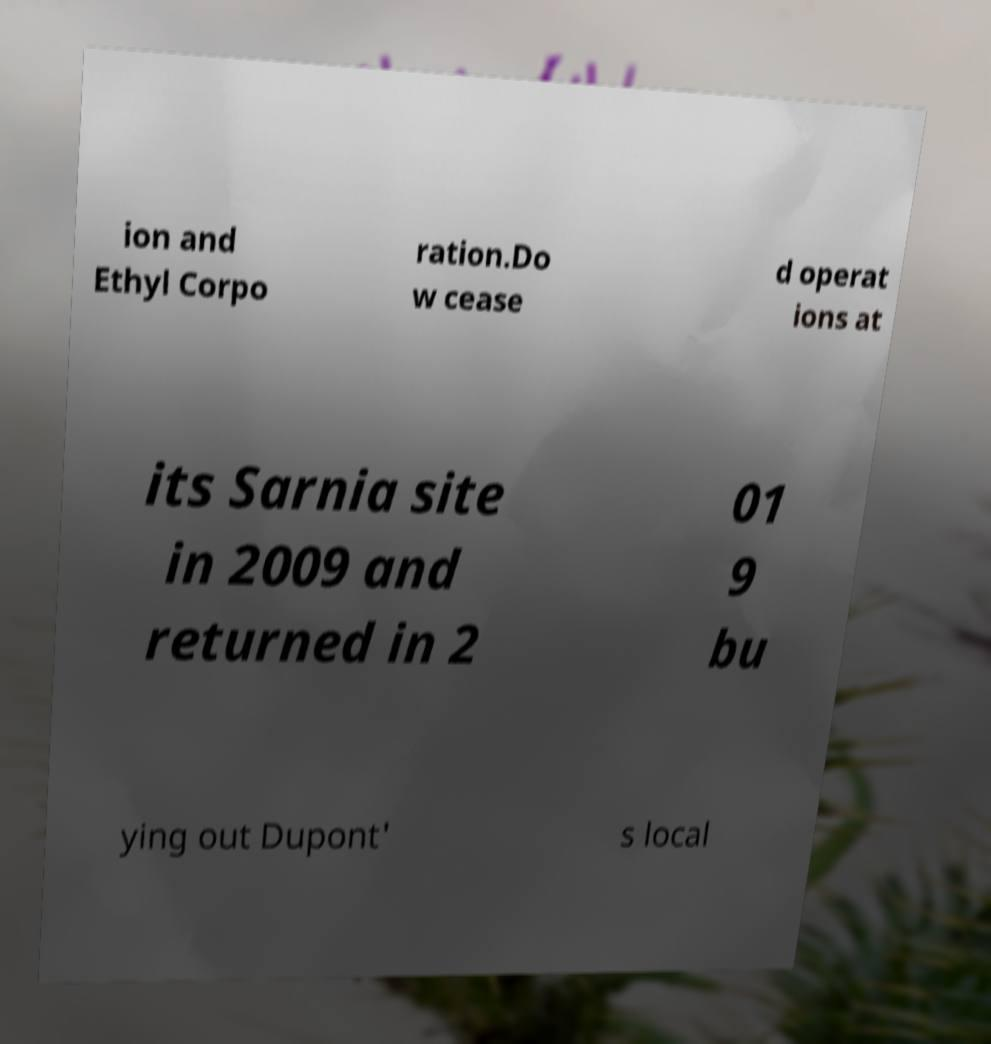For documentation purposes, I need the text within this image transcribed. Could you provide that? ion and Ethyl Corpo ration.Do w cease d operat ions at its Sarnia site in 2009 and returned in 2 01 9 bu ying out Dupont' s local 